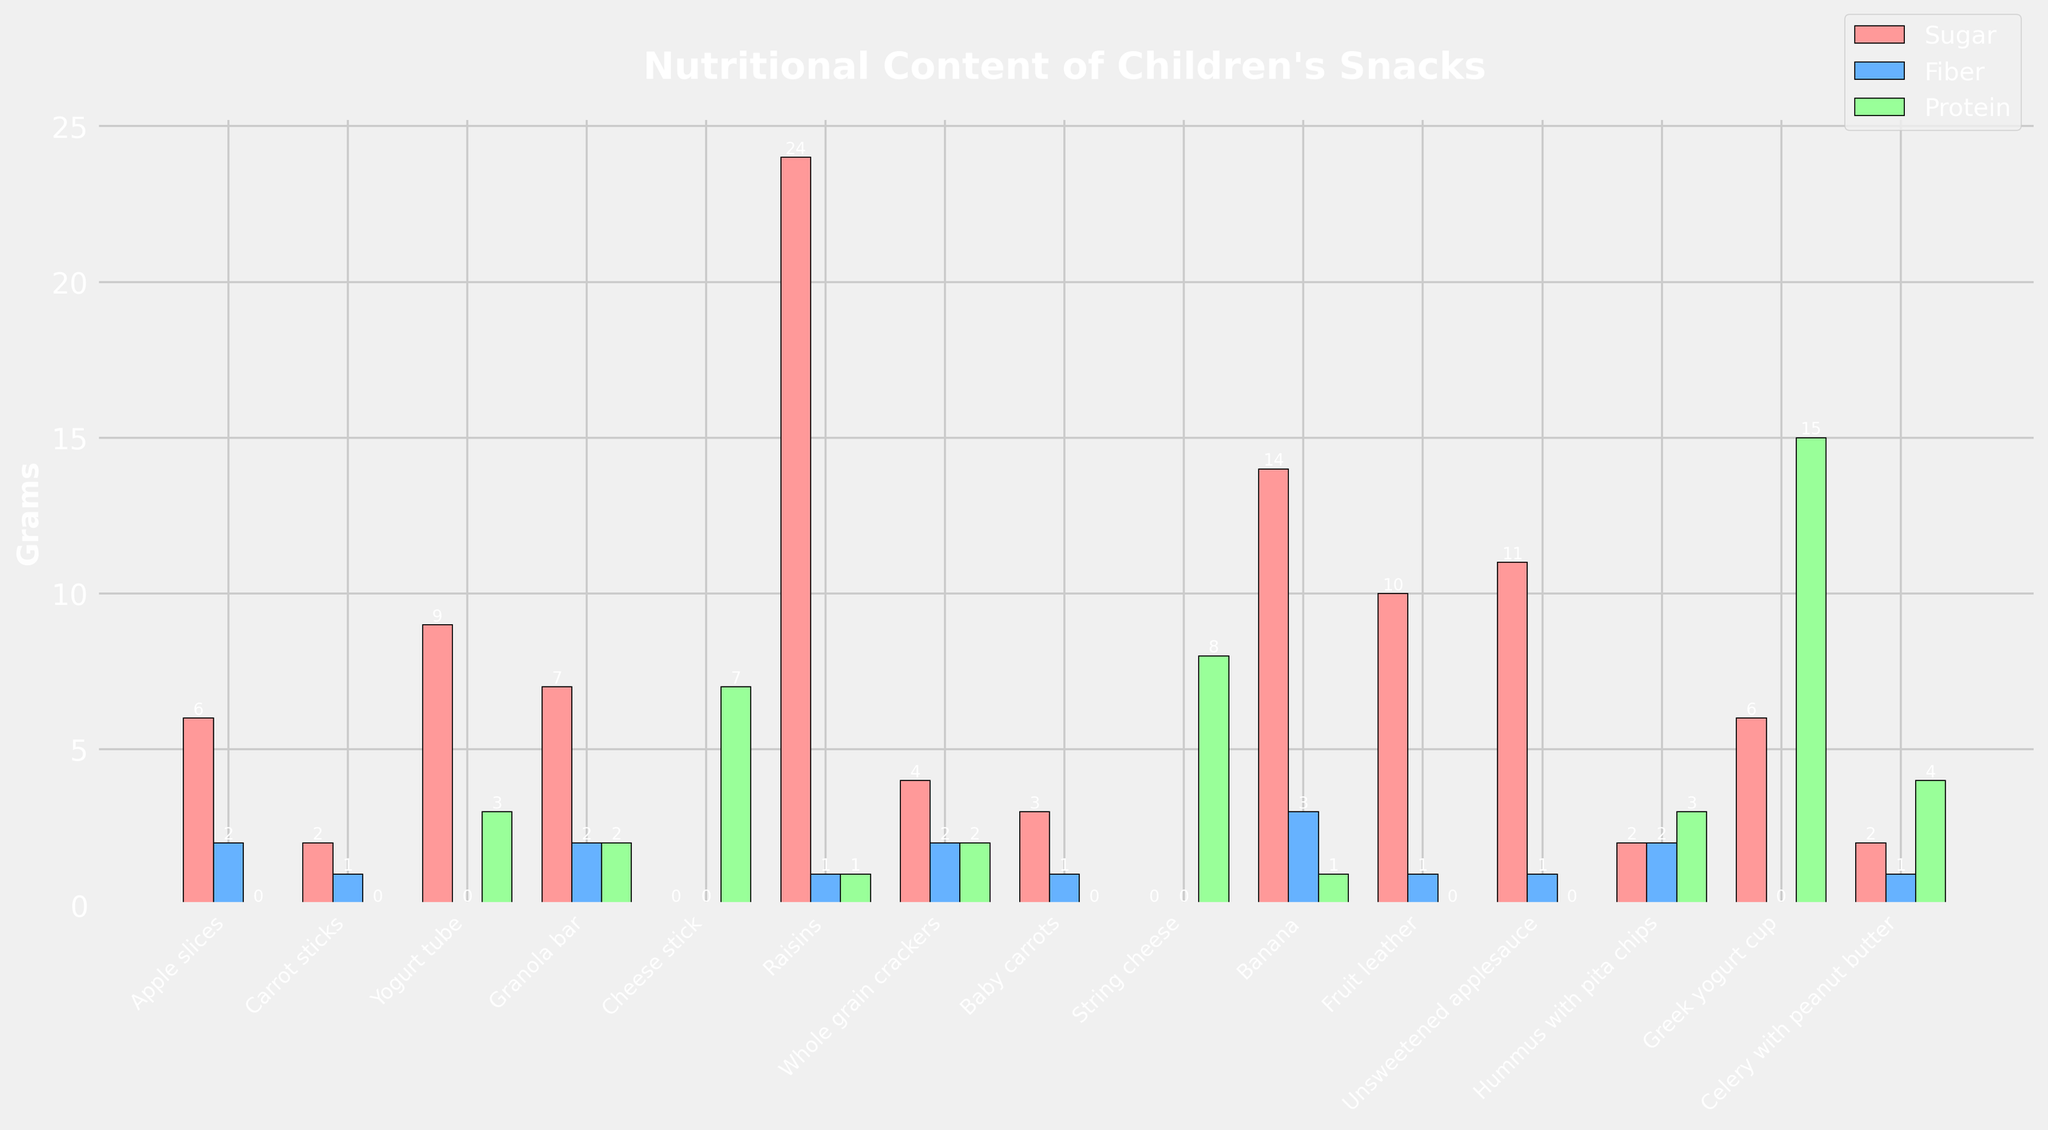Which snack has the highest sugar content? By looking at the heights of the red bars in the chart, the tallest red bar is for Raisins, indicating they have the highest sugar content.
Answer: Raisins Which two snacks have equal amounts of protein? By observing the heights of the green bars in the chart, we can see that Hummus with pita chips and Granola bar have green bars of equal height, indicating they both have 3 grams of protein.
Answer: Hummus with pita chips and Granola bar Which snack has the lowest fiber content? Checking the lowest blue bar in the chart, both Yogurt tube and Greek yogurt cup have zero fiber content indicated by no blue bar present for these snacks.
Answer: Yogurt tube and Greek yogurt cup How much more sugar do Raisins have compared to the Yogurt tube? The sugar content for Raisins is 24 grams and for Yogurt tube, it's 9 grams. Subtracting 9 from 24 gives us 15 grams.
Answer: 15 grams Which snack provides the highest protein content? Observing the tallest green bar in the chart, the tallest green bar corresponds to Greek yogurt cup, which has the highest protein content of 15 grams.
Answer: Greek yogurt cup Which snack has the highest fiber content, and what is it? By looking at the heights of all the blue bars in the chart, we can see that Banana has the tallest blue bar, indicating it has the highest fiber content of 3 grams.
Answer: Banana, 3 grams How does the sugar content of Fruit leather compare to that of a Banana? The red bar for Fruit leather reaches 10 grams, while the red bar for Banana reaches 14 grams, indicating the Banana has 4 grams more sugar than the Fruit leather.
Answer: Banana has 4 grams more Which snack(s) contain 7 grams of protein? Observing the heights of the green bars in the chart, we see that the green bars reaching the height for 7 grams are associated with the Cheese Stick.
Answer: Cheese Stick What is the total amount of fiber found in Whole grain crackers, Carrot sticks, and Apple slices combined? The fiber content for Whole grain crackers is 2 grams, Carrot sticks is 1 gram, and Apple slices is 2 grams. Adding these, 2 + 1 + 2 = 5 grams.
Answer: 5 grams How many snacks have no sugar content? By noting the red bars at height zero, Cheese Stick and String Cheese both have no red bars, indicating no sugar content.
Answer: 2 snacks 